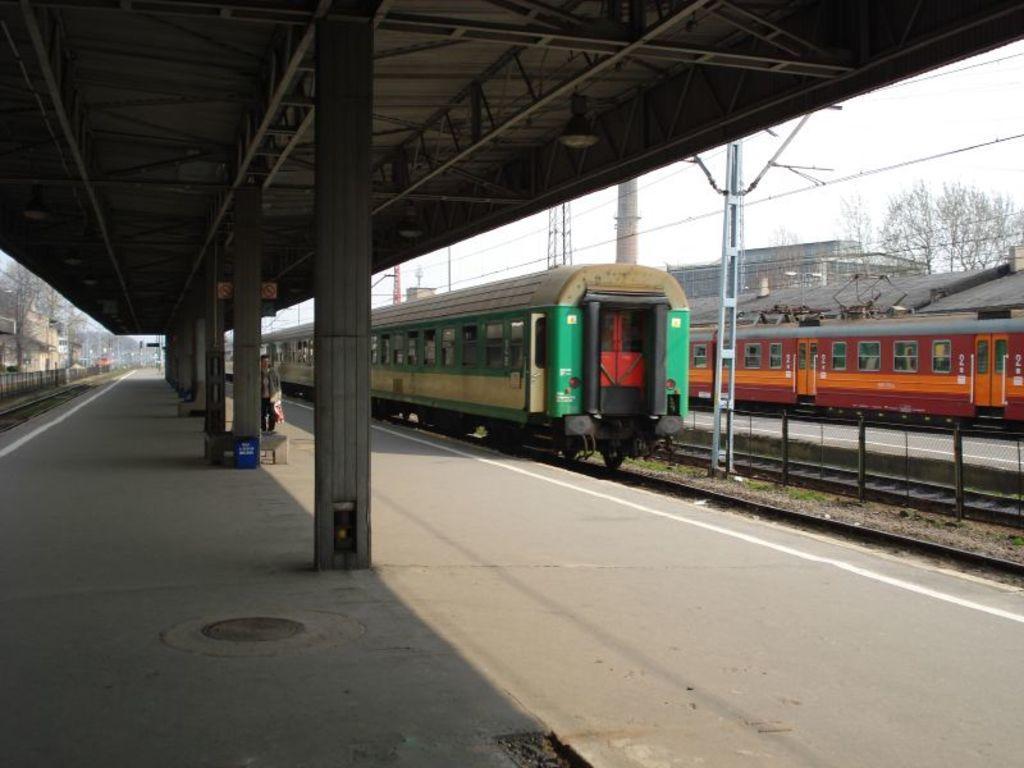How would you summarize this image in a sentence or two? In this image we can see the railway tracks, trains. And we can see the roof with metal frames, pillars. And we can see the metal fencing. And we can see the trees. And we can see the sky, floor. 